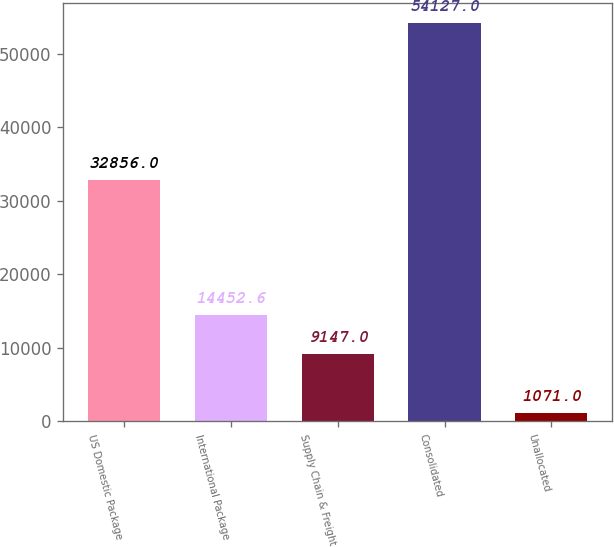Convert chart to OTSL. <chart><loc_0><loc_0><loc_500><loc_500><bar_chart><fcel>US Domestic Package<fcel>International Package<fcel>Supply Chain & Freight<fcel>Consolidated<fcel>Unallocated<nl><fcel>32856<fcel>14452.6<fcel>9147<fcel>54127<fcel>1071<nl></chart> 